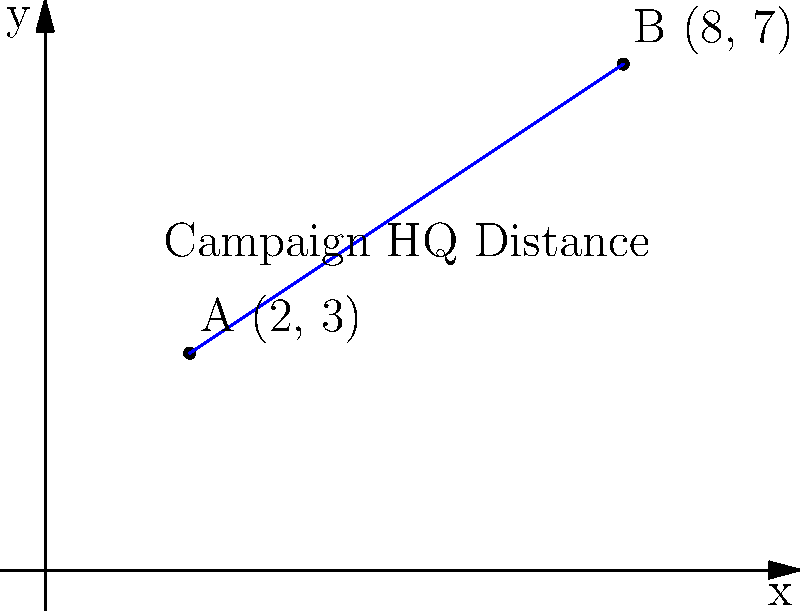As a political reporter, you're covering the upcoming election. Two major candidates have set up their campaign headquarters in different parts of the city. Candidate A's headquarters is located at coordinates (2, 3), while Candidate B's is at (8, 7). Using the distance formula, calculate the straight-line distance between these two campaign headquarters. Round your answer to the nearest tenth of a mile. To solve this problem, we'll use the distance formula, which is derived from the Pythagorean theorem:

$$d = \sqrt{(x_2 - x_1)^2 + (y_2 - y_1)^2}$$

Where $(x_1, y_1)$ is the coordinate of the first point and $(x_2, y_2)$ is the coordinate of the second point.

Step 1: Identify the coordinates
- Candidate A's headquarters: $(x_1, y_1) = (2, 3)$
- Candidate B's headquarters: $(x_2, y_2) = (8, 7)$

Step 2: Plug the values into the distance formula
$$d = \sqrt{(8 - 2)^2 + (7 - 3)^2}$$

Step 3: Simplify the expressions inside the parentheses
$$d = \sqrt{6^2 + 4^2}$$

Step 4: Calculate the squares
$$d = \sqrt{36 + 16}$$

Step 5: Add the values under the square root
$$d = \sqrt{52}$$

Step 6: Calculate the square root and round to the nearest tenth
$$d \approx 7.2$$

Therefore, the distance between the two campaign headquarters is approximately 7.2 miles.
Answer: 7.2 miles 